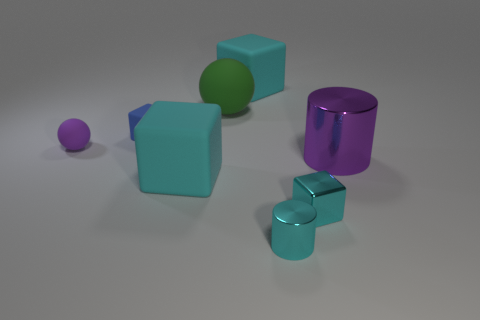The small metallic cube that is to the right of the big cyan block that is behind the purple metallic cylinder is what color?
Ensure brevity in your answer.  Cyan. How many other things are the same shape as the big purple metal object?
Your answer should be compact. 1. Are there any large cylinders that have the same material as the big green object?
Keep it short and to the point. No. There is a cyan cube that is the same size as the purple rubber ball; what is it made of?
Your answer should be very brief. Metal. There is a shiny cylinder behind the metallic cylinder in front of the large rubber block that is in front of the green thing; what is its color?
Give a very brief answer. Purple. Does the big rubber object that is in front of the blue matte cube have the same shape as the cyan metallic object behind the cyan cylinder?
Your answer should be very brief. Yes. How many purple matte things are there?
Your answer should be compact. 1. There is a sphere that is the same size as the cyan metallic cylinder; what is its color?
Ensure brevity in your answer.  Purple. Are the blue thing that is behind the purple cylinder and the small object right of the tiny cyan cylinder made of the same material?
Provide a short and direct response. No. There is a metallic cylinder that is on the right side of the cyan object in front of the small metallic block; what size is it?
Make the answer very short. Large. 